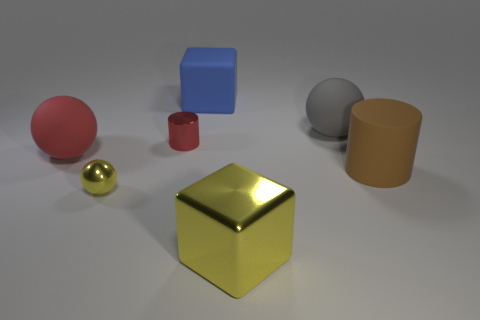Subtract all tiny yellow spheres. How many spheres are left? 2 Add 1 yellow objects. How many objects exist? 8 Add 3 brown objects. How many brown objects are left? 4 Add 5 cyan cylinders. How many cyan cylinders exist? 5 Subtract all gray spheres. How many spheres are left? 2 Subtract 1 red cylinders. How many objects are left? 6 Subtract all spheres. How many objects are left? 4 Subtract 1 balls. How many balls are left? 2 Subtract all purple balls. Subtract all cyan cylinders. How many balls are left? 3 Subtract all green balls. How many purple cubes are left? 0 